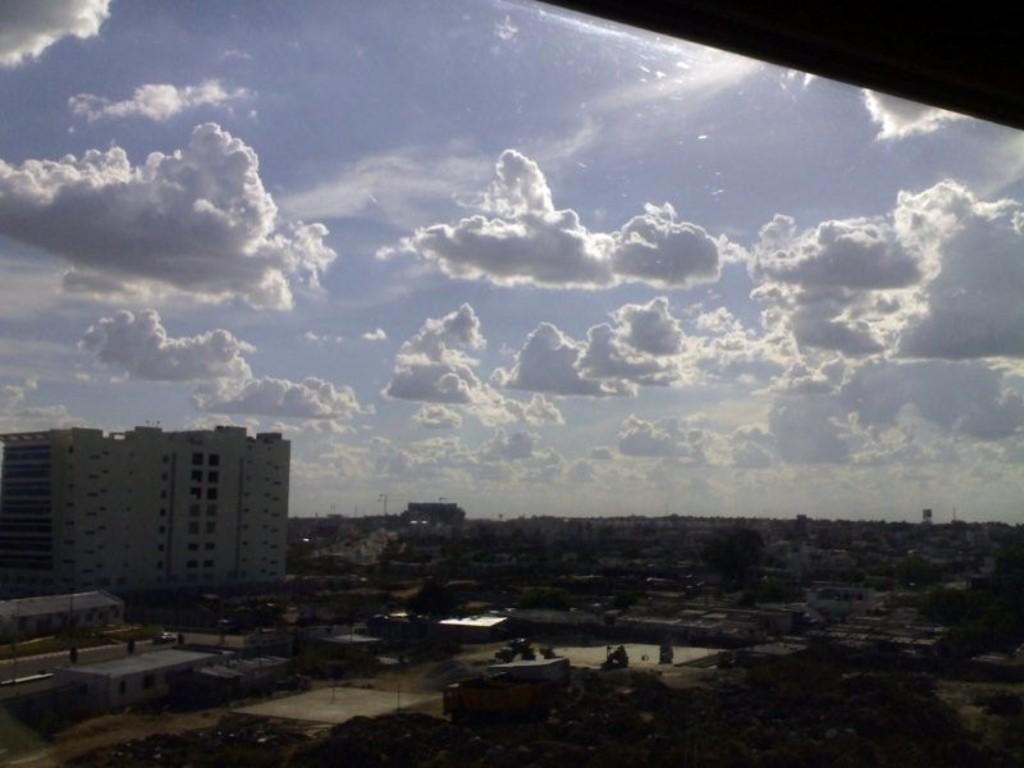Could you give a brief overview of what you see in this image? This image is taken outdoors. At the top of the image there is a sky with clouds. At the bottom there are many buildings and houses on the ground and there are a few trees and plants. 